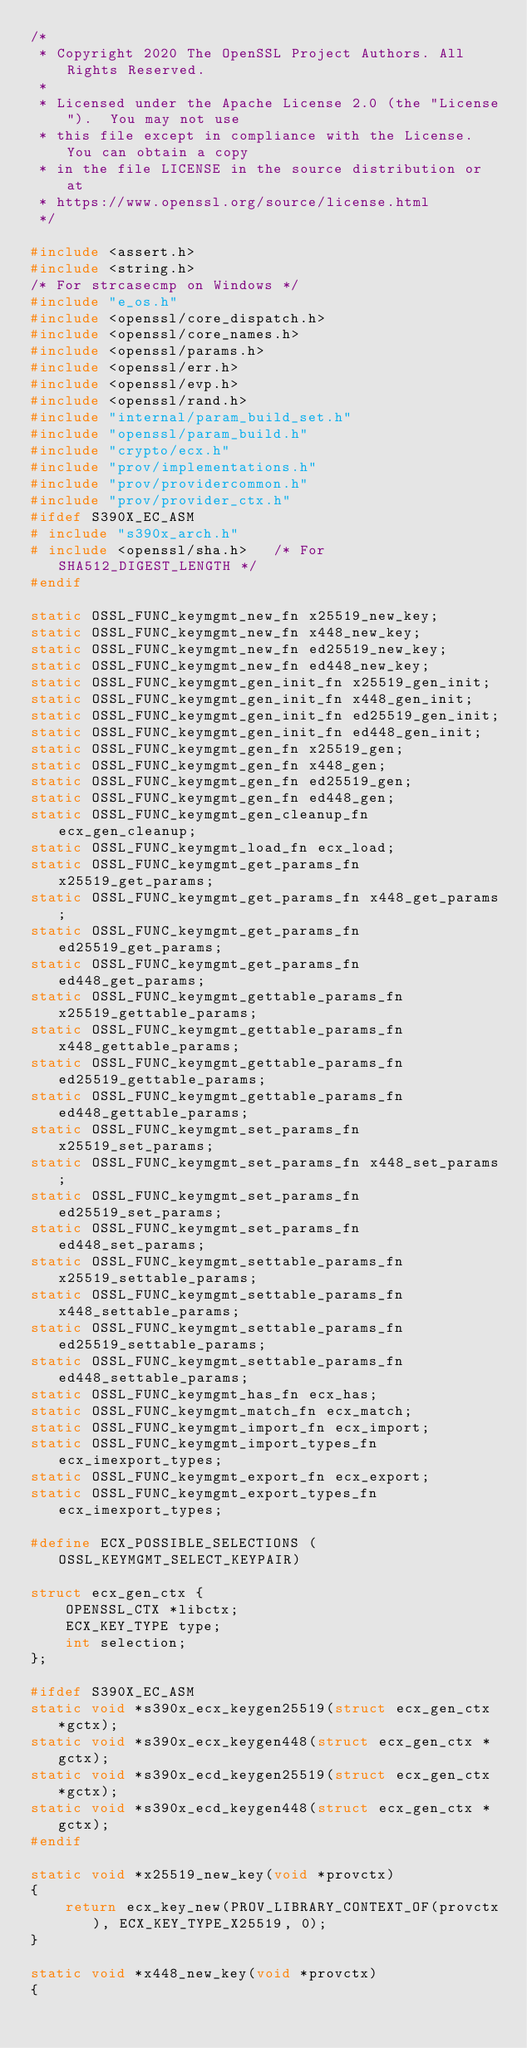Convert code to text. <code><loc_0><loc_0><loc_500><loc_500><_C_>/*
 * Copyright 2020 The OpenSSL Project Authors. All Rights Reserved.
 *
 * Licensed under the Apache License 2.0 (the "License").  You may not use
 * this file except in compliance with the License.  You can obtain a copy
 * in the file LICENSE in the source distribution or at
 * https://www.openssl.org/source/license.html
 */

#include <assert.h>
#include <string.h>
/* For strcasecmp on Windows */
#include "e_os.h"
#include <openssl/core_dispatch.h>
#include <openssl/core_names.h>
#include <openssl/params.h>
#include <openssl/err.h>
#include <openssl/evp.h>
#include <openssl/rand.h>
#include "internal/param_build_set.h"
#include "openssl/param_build.h"
#include "crypto/ecx.h"
#include "prov/implementations.h"
#include "prov/providercommon.h"
#include "prov/provider_ctx.h"
#ifdef S390X_EC_ASM
# include "s390x_arch.h"
# include <openssl/sha.h>   /* For SHA512_DIGEST_LENGTH */
#endif

static OSSL_FUNC_keymgmt_new_fn x25519_new_key;
static OSSL_FUNC_keymgmt_new_fn x448_new_key;
static OSSL_FUNC_keymgmt_new_fn ed25519_new_key;
static OSSL_FUNC_keymgmt_new_fn ed448_new_key;
static OSSL_FUNC_keymgmt_gen_init_fn x25519_gen_init;
static OSSL_FUNC_keymgmt_gen_init_fn x448_gen_init;
static OSSL_FUNC_keymgmt_gen_init_fn ed25519_gen_init;
static OSSL_FUNC_keymgmt_gen_init_fn ed448_gen_init;
static OSSL_FUNC_keymgmt_gen_fn x25519_gen;
static OSSL_FUNC_keymgmt_gen_fn x448_gen;
static OSSL_FUNC_keymgmt_gen_fn ed25519_gen;
static OSSL_FUNC_keymgmt_gen_fn ed448_gen;
static OSSL_FUNC_keymgmt_gen_cleanup_fn ecx_gen_cleanup;
static OSSL_FUNC_keymgmt_load_fn ecx_load;
static OSSL_FUNC_keymgmt_get_params_fn x25519_get_params;
static OSSL_FUNC_keymgmt_get_params_fn x448_get_params;
static OSSL_FUNC_keymgmt_get_params_fn ed25519_get_params;
static OSSL_FUNC_keymgmt_get_params_fn ed448_get_params;
static OSSL_FUNC_keymgmt_gettable_params_fn x25519_gettable_params;
static OSSL_FUNC_keymgmt_gettable_params_fn x448_gettable_params;
static OSSL_FUNC_keymgmt_gettable_params_fn ed25519_gettable_params;
static OSSL_FUNC_keymgmt_gettable_params_fn ed448_gettable_params;
static OSSL_FUNC_keymgmt_set_params_fn x25519_set_params;
static OSSL_FUNC_keymgmt_set_params_fn x448_set_params;
static OSSL_FUNC_keymgmt_set_params_fn ed25519_set_params;
static OSSL_FUNC_keymgmt_set_params_fn ed448_set_params;
static OSSL_FUNC_keymgmt_settable_params_fn x25519_settable_params;
static OSSL_FUNC_keymgmt_settable_params_fn x448_settable_params;
static OSSL_FUNC_keymgmt_settable_params_fn ed25519_settable_params;
static OSSL_FUNC_keymgmt_settable_params_fn ed448_settable_params;
static OSSL_FUNC_keymgmt_has_fn ecx_has;
static OSSL_FUNC_keymgmt_match_fn ecx_match;
static OSSL_FUNC_keymgmt_import_fn ecx_import;
static OSSL_FUNC_keymgmt_import_types_fn ecx_imexport_types;
static OSSL_FUNC_keymgmt_export_fn ecx_export;
static OSSL_FUNC_keymgmt_export_types_fn ecx_imexport_types;

#define ECX_POSSIBLE_SELECTIONS (OSSL_KEYMGMT_SELECT_KEYPAIR)

struct ecx_gen_ctx {
    OPENSSL_CTX *libctx;
    ECX_KEY_TYPE type;
    int selection;
};

#ifdef S390X_EC_ASM
static void *s390x_ecx_keygen25519(struct ecx_gen_ctx *gctx);
static void *s390x_ecx_keygen448(struct ecx_gen_ctx *gctx);
static void *s390x_ecd_keygen25519(struct ecx_gen_ctx *gctx);
static void *s390x_ecd_keygen448(struct ecx_gen_ctx *gctx);
#endif

static void *x25519_new_key(void *provctx)
{
    return ecx_key_new(PROV_LIBRARY_CONTEXT_OF(provctx), ECX_KEY_TYPE_X25519, 0);
}

static void *x448_new_key(void *provctx)
{</code> 